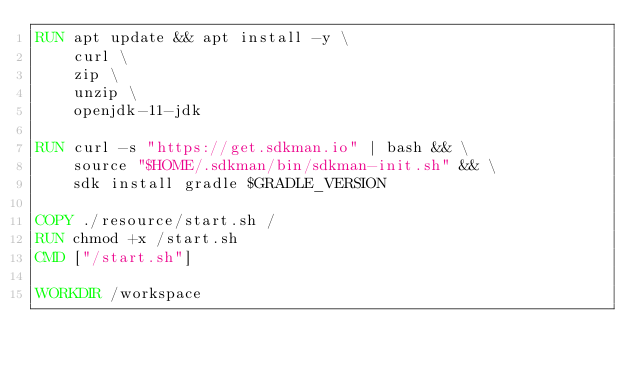<code> <loc_0><loc_0><loc_500><loc_500><_Dockerfile_>RUN apt update && apt install -y \
    curl \
    zip \
    unzip \
    openjdk-11-jdk

RUN curl -s "https://get.sdkman.io" | bash && \
    source "$HOME/.sdkman/bin/sdkman-init.sh" && \
    sdk install gradle $GRADLE_VERSION

COPY ./resource/start.sh /
RUN chmod +x /start.sh
CMD ["/start.sh"]

WORKDIR /workspace
</code> 